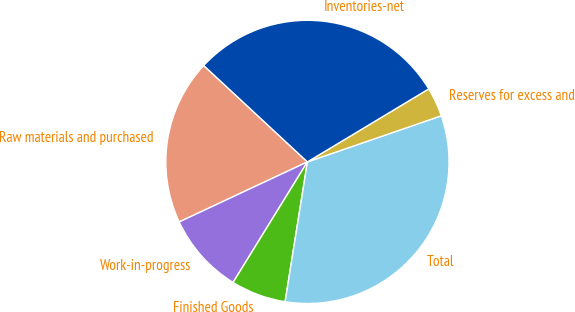<chart> <loc_0><loc_0><loc_500><loc_500><pie_chart><fcel>Raw materials and purchased<fcel>Work-in-progress<fcel>Finished Goods<fcel>Total<fcel>Reserves for excess and<fcel>Inventories-net<nl><fcel>18.89%<fcel>9.23%<fcel>6.28%<fcel>32.8%<fcel>3.34%<fcel>29.46%<nl></chart> 